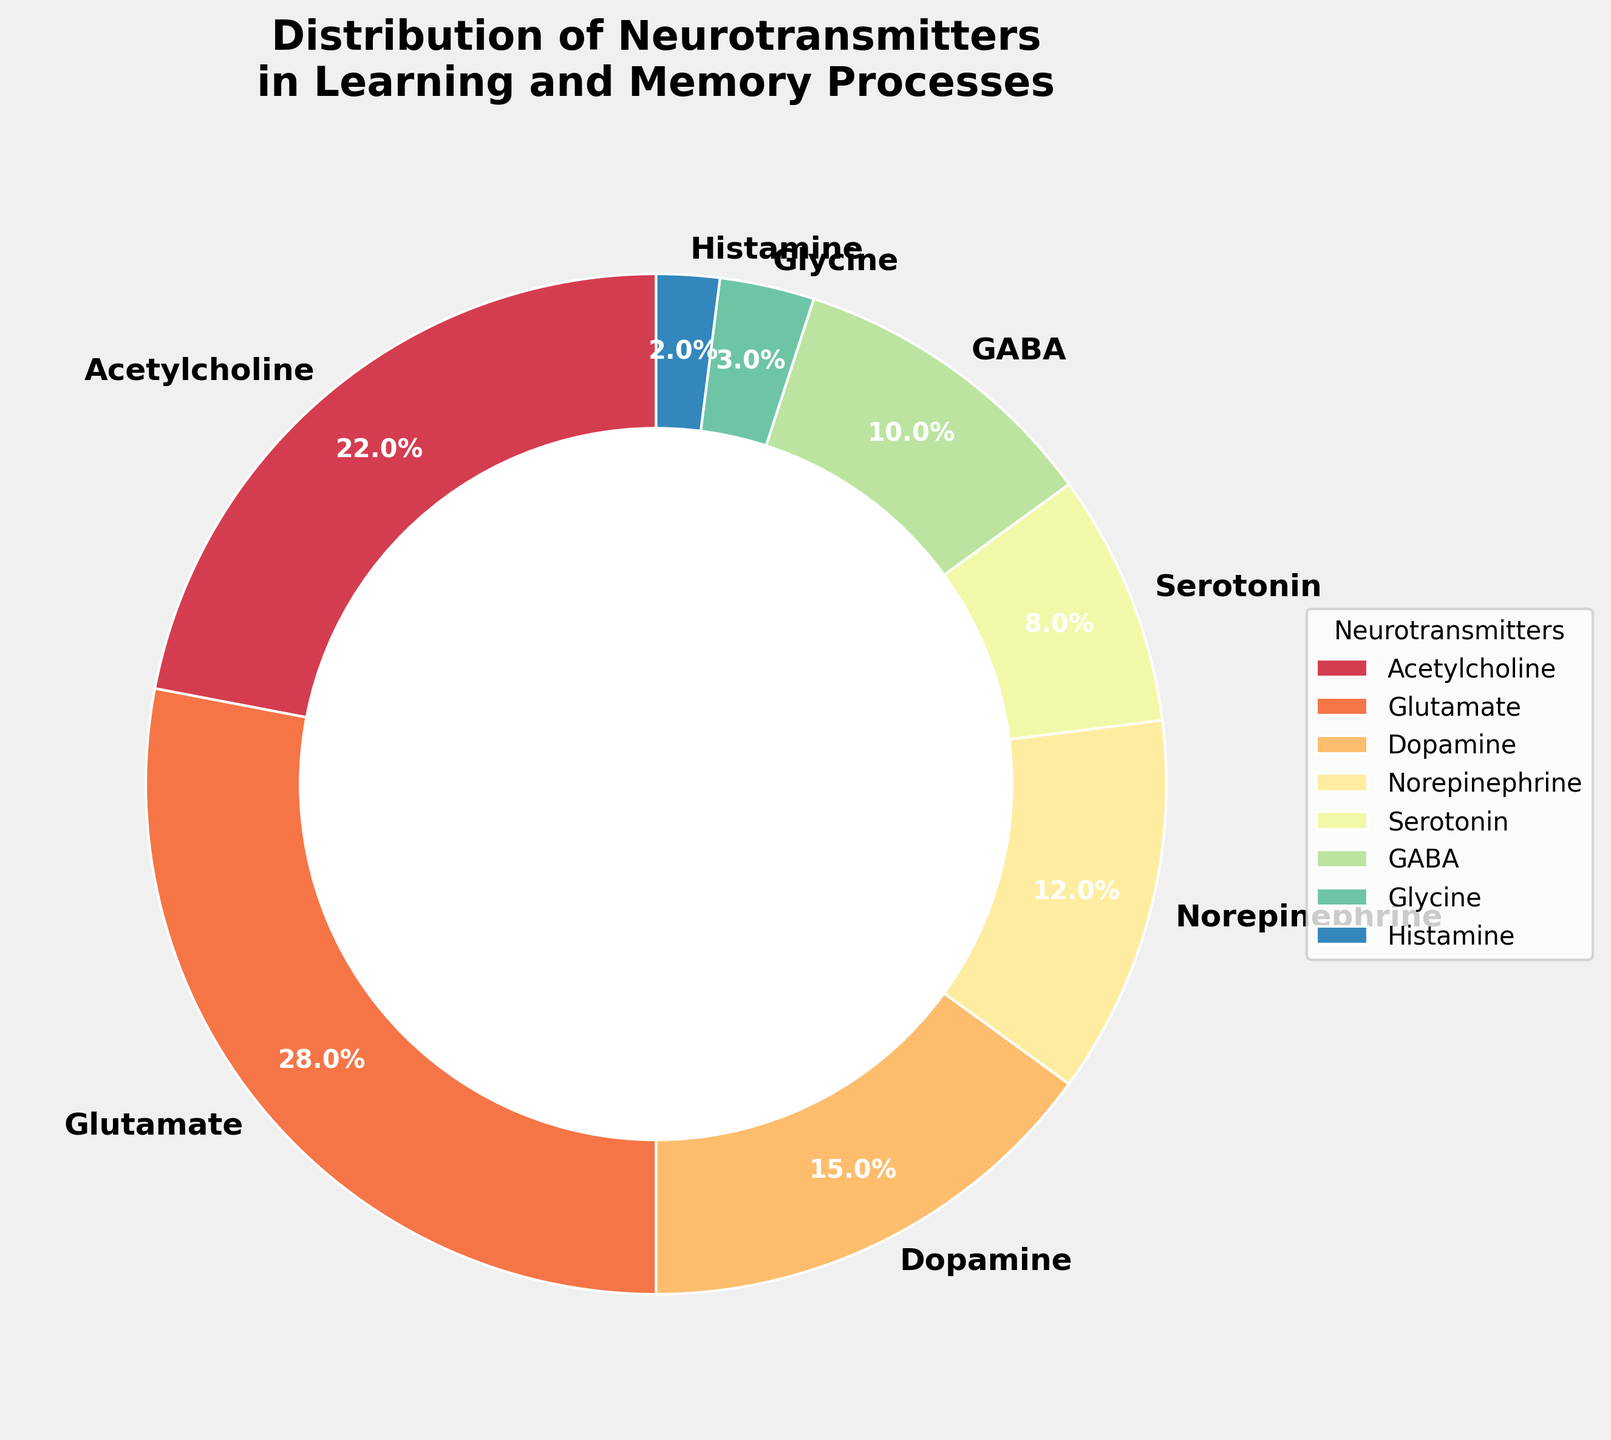Which neurotransmitter is the most prevalent according to the distribution figure? Identify the slice with the largest percentage and its corresponding label. The slice with 28% corresponds to Glutamate.
Answer: Glutamate Which neurotransmitter has the smallest percentage in the distribution? Find the slice with the smallest percentage. The slice with 2% corresponds to Histamine.
Answer: Histamine What is the combined percentage of Dopamine and Norepinephrine? Add the percentages for Dopamine (15%) and Norepinephrine (12%). The sum is 15% + 12% = 27%.
Answer: 27% How does the percentage of Acetylcholine compare to that of Serotonin? Compare the percentages for Acetylcholine (22%) and Serotonin (8%). Acetylcholine is greater than Serotonin by 22% - 8% = 14%.
Answer: 14% greater How many neurotransmitters have a percentage lower than 10%? Count the slices with percentages lower than 10%. These slices are for Serotonin (8%), GABA (10%), Glycine (3%), and Histamine (2%). Although GABA is exactly 10%, it is typically considered in the less-than-10% category. Therefore, four neurotransmitters: Serotonin, GABA, Glycine, and Histamine.
Answer: 4 What is the difference in percentage between the highest and the lowest neurotransmitter distribution? Identify the percentages of the highest (Glutamate at 28%) and the lowest (Histamine at 2%) neurotransmitters. The difference is 28% - 2% = 26%.
Answer: 26% Which neurotransmitter occupies the second-largest segment in the pie chart? Find the second-largest percentage after Glutamate (28%). The next largest is Acetylcholine at 22%.
Answer: Acetylcholine What is the combined percentage of neurotransmitters involved in inhibitory processes (GABA and Glycine)? Add the percentages for GABA (10%) and Glycine (3%). The sum is 10% + 3% = 13%.
Answer: 13% What proportion of the neurotransmitters have a percentage equal to or greater than 15%? Identify the neurotransmitters equal to or greater than 15%: Glutamate (28%), Acetylcholine (22%), and Dopamine (15%). There are 3 out of 8 neurotransmitters, so the proportion is 3/8.
Answer: 3 out of 8 How does the combined percentage of GABA and Histamine compare to that of the largest neurotransmitter segment? Add the percentages for GABA (10%) and Histamine (2%). The sum is 10% + 2% = 12%. Compare it to Glutamate (28%). GABA and Histamine together (12%) are 16% less than Glutamate (28% - 12%).
Answer: 16% less 